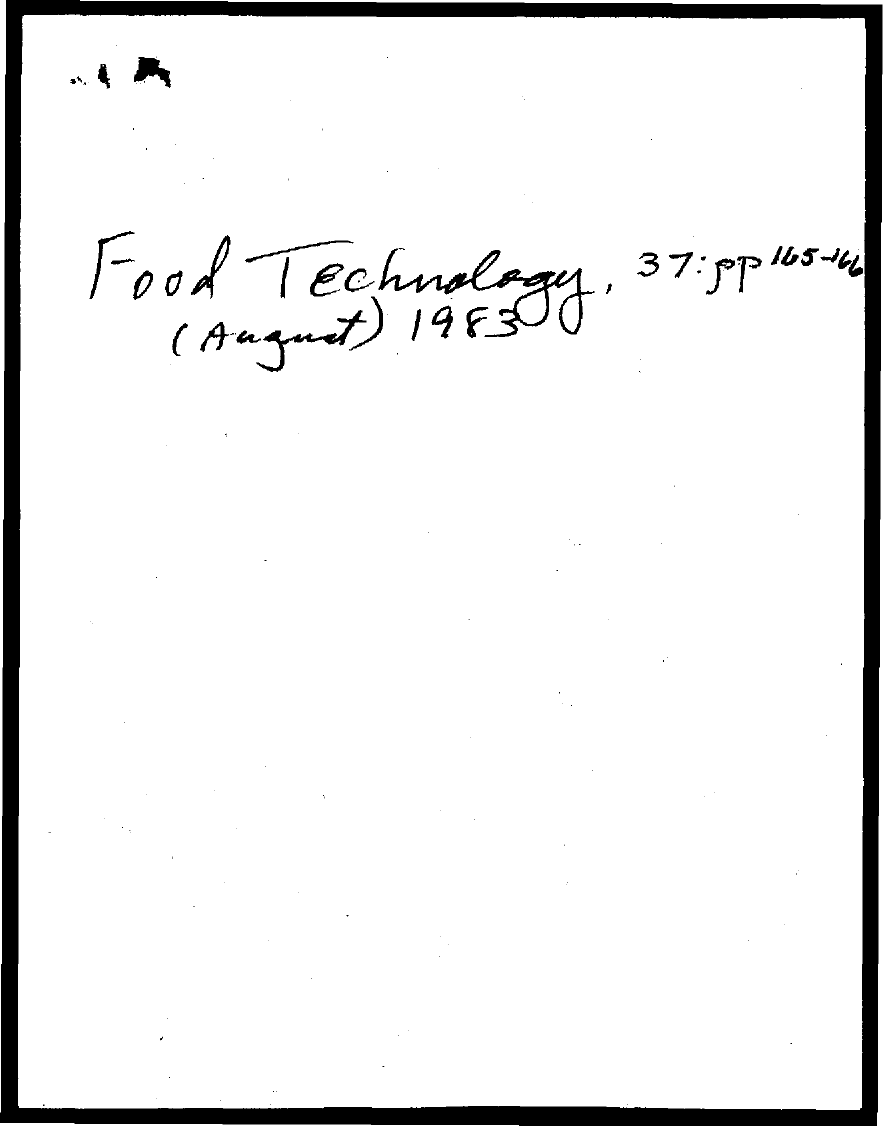Mention a couple of crucial points in this snapshot. The document mentions August. The year mentioned in the document is 1983. 